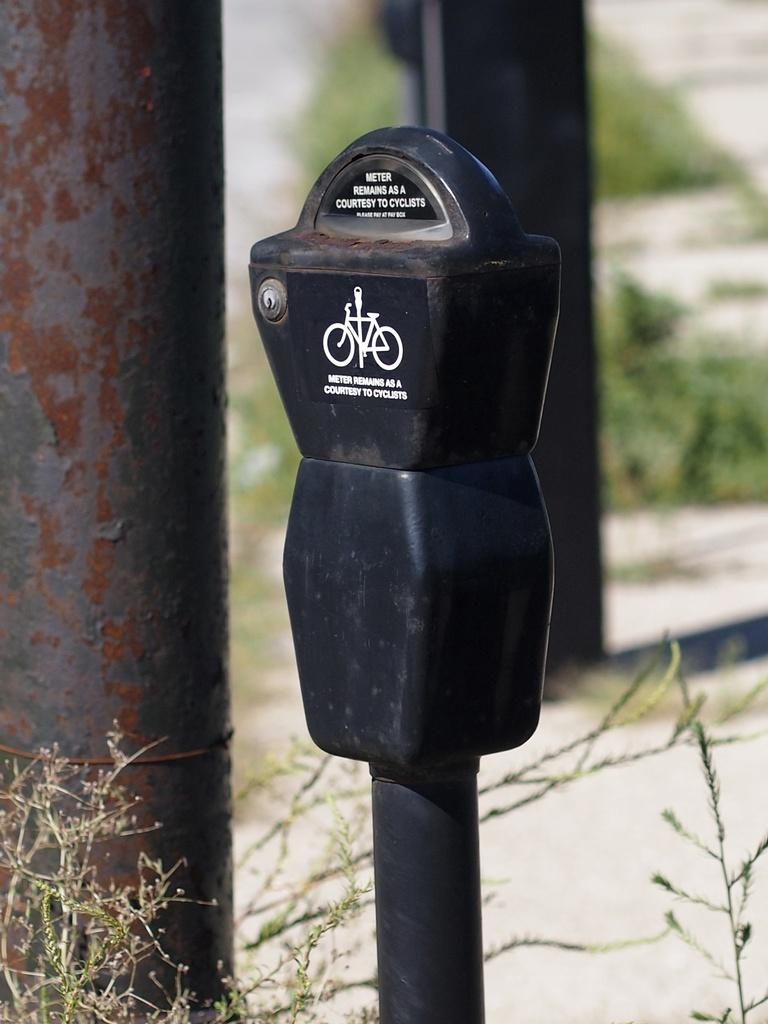<image>
Offer a succinct explanation of the picture presented. A parking meter in a grassy area that says Meter remains as a courtesy to cyclists. 